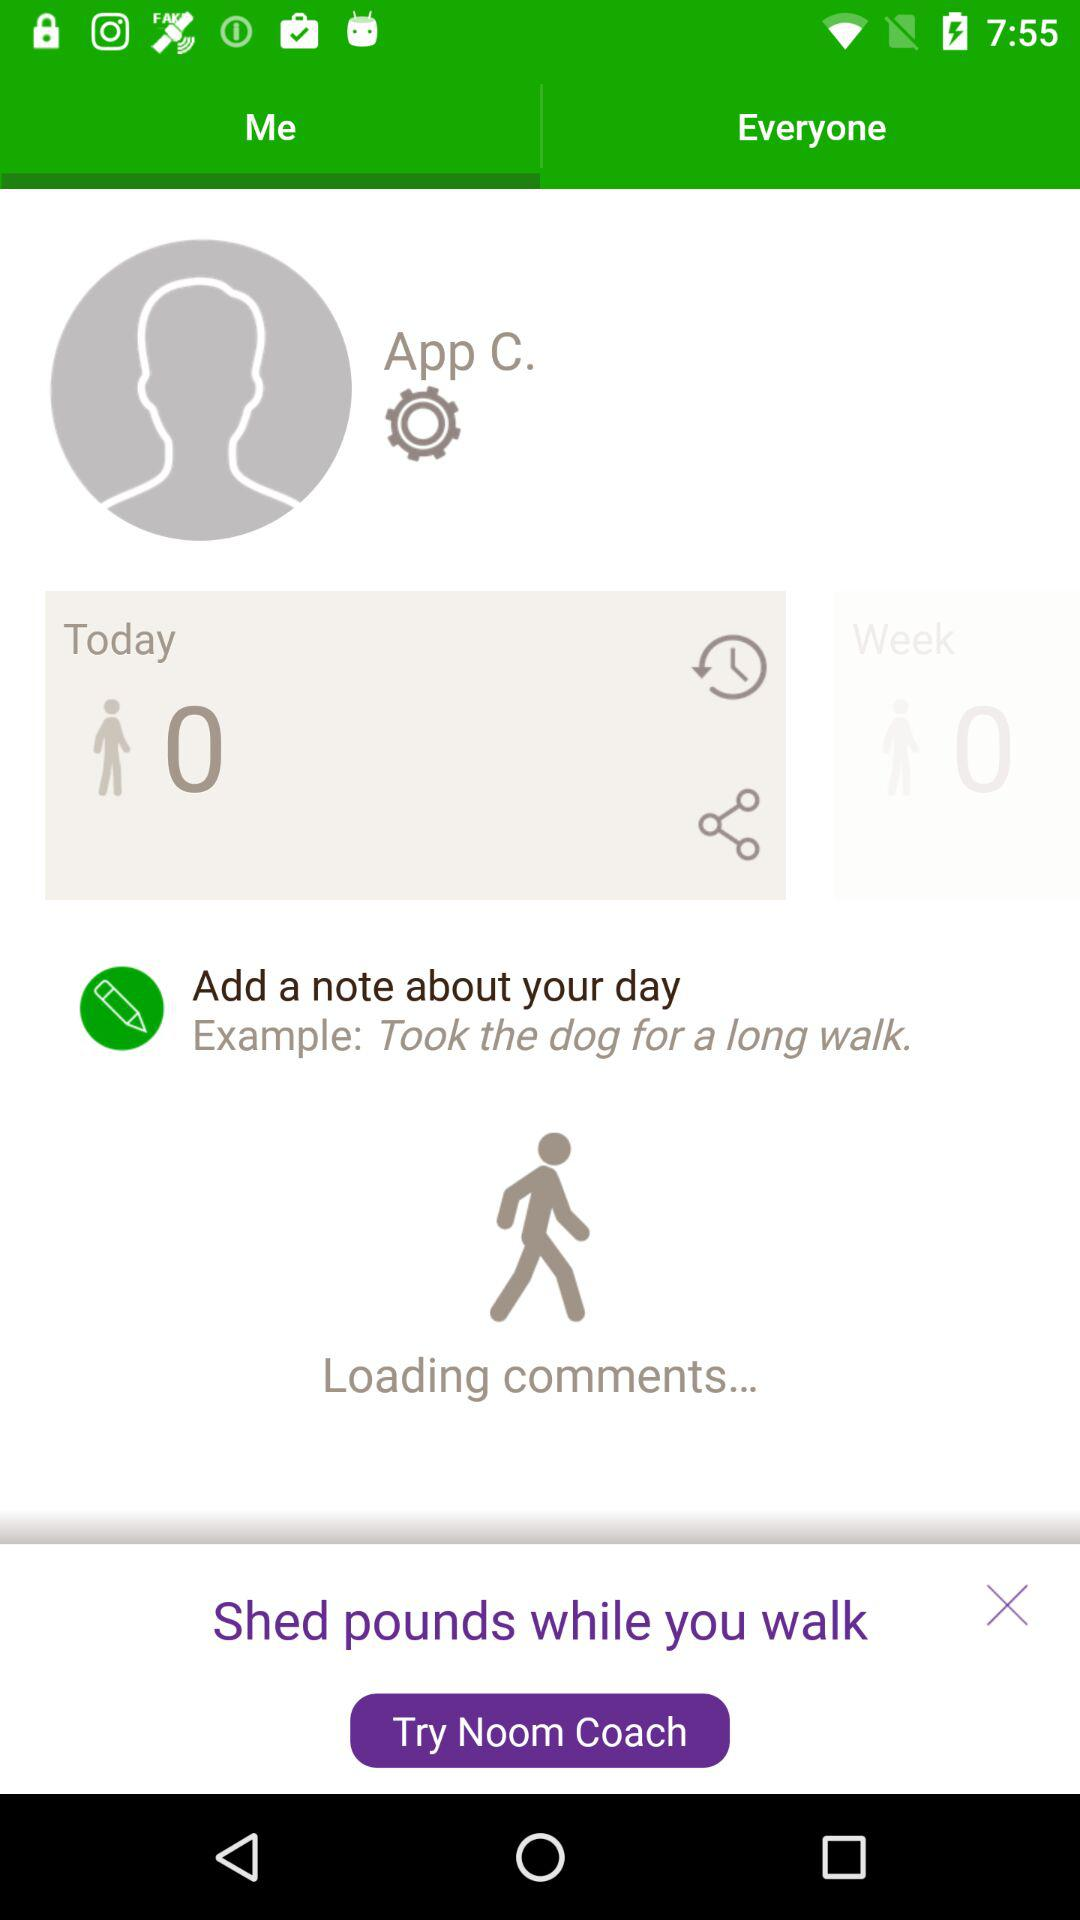Which tab is selected? The selected tab is "Me". 